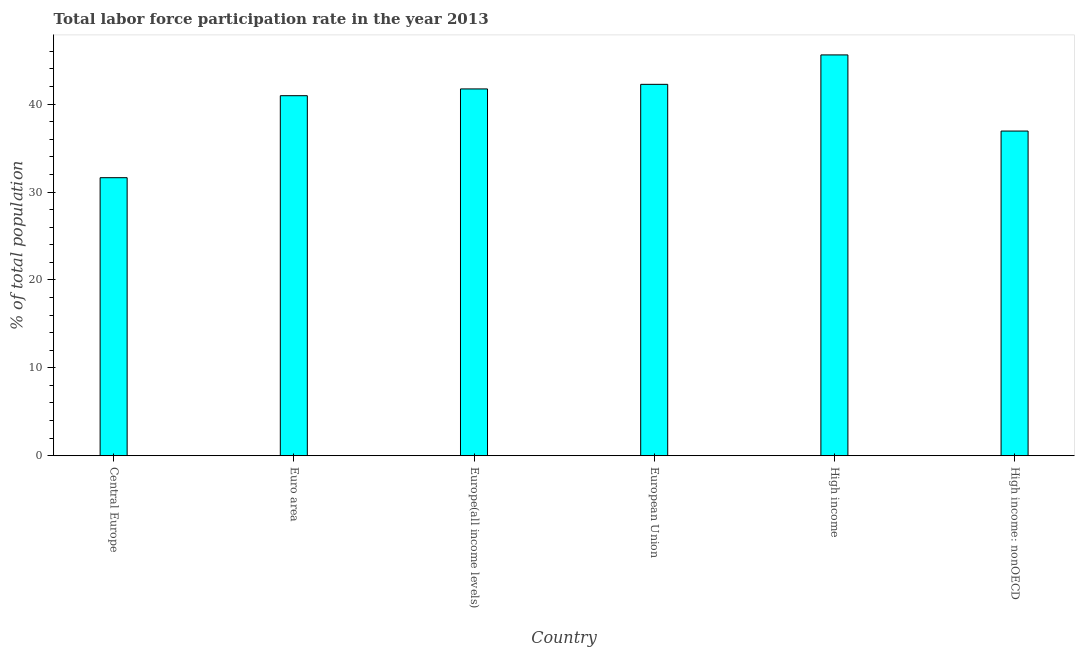Does the graph contain grids?
Make the answer very short. No. What is the title of the graph?
Keep it short and to the point. Total labor force participation rate in the year 2013. What is the label or title of the X-axis?
Offer a terse response. Country. What is the label or title of the Y-axis?
Your answer should be very brief. % of total population. What is the total labor force participation rate in High income: nonOECD?
Make the answer very short. 36.94. Across all countries, what is the maximum total labor force participation rate?
Offer a terse response. 45.6. Across all countries, what is the minimum total labor force participation rate?
Your answer should be compact. 31.63. In which country was the total labor force participation rate maximum?
Provide a short and direct response. High income. In which country was the total labor force participation rate minimum?
Your answer should be very brief. Central Europe. What is the sum of the total labor force participation rate?
Ensure brevity in your answer.  239.12. What is the difference between the total labor force participation rate in Central Europe and Euro area?
Your answer should be very brief. -9.33. What is the average total labor force participation rate per country?
Give a very brief answer. 39.85. What is the median total labor force participation rate?
Ensure brevity in your answer.  41.35. In how many countries, is the total labor force participation rate greater than 12 %?
Your response must be concise. 6. What is the ratio of the total labor force participation rate in Central Europe to that in High income?
Your answer should be compact. 0.69. Is the difference between the total labor force participation rate in Central Europe and High income greater than the difference between any two countries?
Offer a very short reply. Yes. What is the difference between the highest and the second highest total labor force participation rate?
Your response must be concise. 3.35. Is the sum of the total labor force participation rate in High income and High income: nonOECD greater than the maximum total labor force participation rate across all countries?
Your answer should be very brief. Yes. What is the difference between the highest and the lowest total labor force participation rate?
Provide a succinct answer. 13.97. In how many countries, is the total labor force participation rate greater than the average total labor force participation rate taken over all countries?
Make the answer very short. 4. Are all the bars in the graph horizontal?
Your answer should be compact. No. What is the difference between two consecutive major ticks on the Y-axis?
Provide a succinct answer. 10. What is the % of total population in Central Europe?
Your response must be concise. 31.63. What is the % of total population of Euro area?
Your answer should be compact. 40.96. What is the % of total population of Europe(all income levels)?
Keep it short and to the point. 41.73. What is the % of total population in European Union?
Your response must be concise. 42.25. What is the % of total population in High income?
Offer a terse response. 45.6. What is the % of total population in High income: nonOECD?
Keep it short and to the point. 36.94. What is the difference between the % of total population in Central Europe and Euro area?
Your response must be concise. -9.33. What is the difference between the % of total population in Central Europe and Europe(all income levels)?
Keep it short and to the point. -10.1. What is the difference between the % of total population in Central Europe and European Union?
Provide a short and direct response. -10.62. What is the difference between the % of total population in Central Europe and High income?
Ensure brevity in your answer.  -13.97. What is the difference between the % of total population in Central Europe and High income: nonOECD?
Ensure brevity in your answer.  -5.31. What is the difference between the % of total population in Euro area and Europe(all income levels)?
Provide a succinct answer. -0.77. What is the difference between the % of total population in Euro area and European Union?
Offer a very short reply. -1.29. What is the difference between the % of total population in Euro area and High income?
Give a very brief answer. -4.64. What is the difference between the % of total population in Euro area and High income: nonOECD?
Ensure brevity in your answer.  4.02. What is the difference between the % of total population in Europe(all income levels) and European Union?
Your response must be concise. -0.52. What is the difference between the % of total population in Europe(all income levels) and High income?
Offer a very short reply. -3.87. What is the difference between the % of total population in Europe(all income levels) and High income: nonOECD?
Give a very brief answer. 4.79. What is the difference between the % of total population in European Union and High income?
Offer a terse response. -3.35. What is the difference between the % of total population in European Union and High income: nonOECD?
Ensure brevity in your answer.  5.32. What is the difference between the % of total population in High income and High income: nonOECD?
Offer a terse response. 8.66. What is the ratio of the % of total population in Central Europe to that in Euro area?
Give a very brief answer. 0.77. What is the ratio of the % of total population in Central Europe to that in Europe(all income levels)?
Provide a short and direct response. 0.76. What is the ratio of the % of total population in Central Europe to that in European Union?
Give a very brief answer. 0.75. What is the ratio of the % of total population in Central Europe to that in High income?
Your response must be concise. 0.69. What is the ratio of the % of total population in Central Europe to that in High income: nonOECD?
Offer a very short reply. 0.86. What is the ratio of the % of total population in Euro area to that in Europe(all income levels)?
Offer a very short reply. 0.98. What is the ratio of the % of total population in Euro area to that in European Union?
Offer a terse response. 0.97. What is the ratio of the % of total population in Euro area to that in High income?
Offer a terse response. 0.9. What is the ratio of the % of total population in Euro area to that in High income: nonOECD?
Offer a very short reply. 1.11. What is the ratio of the % of total population in Europe(all income levels) to that in High income?
Provide a short and direct response. 0.92. What is the ratio of the % of total population in Europe(all income levels) to that in High income: nonOECD?
Provide a short and direct response. 1.13. What is the ratio of the % of total population in European Union to that in High income?
Your answer should be compact. 0.93. What is the ratio of the % of total population in European Union to that in High income: nonOECD?
Provide a short and direct response. 1.14. What is the ratio of the % of total population in High income to that in High income: nonOECD?
Provide a succinct answer. 1.24. 